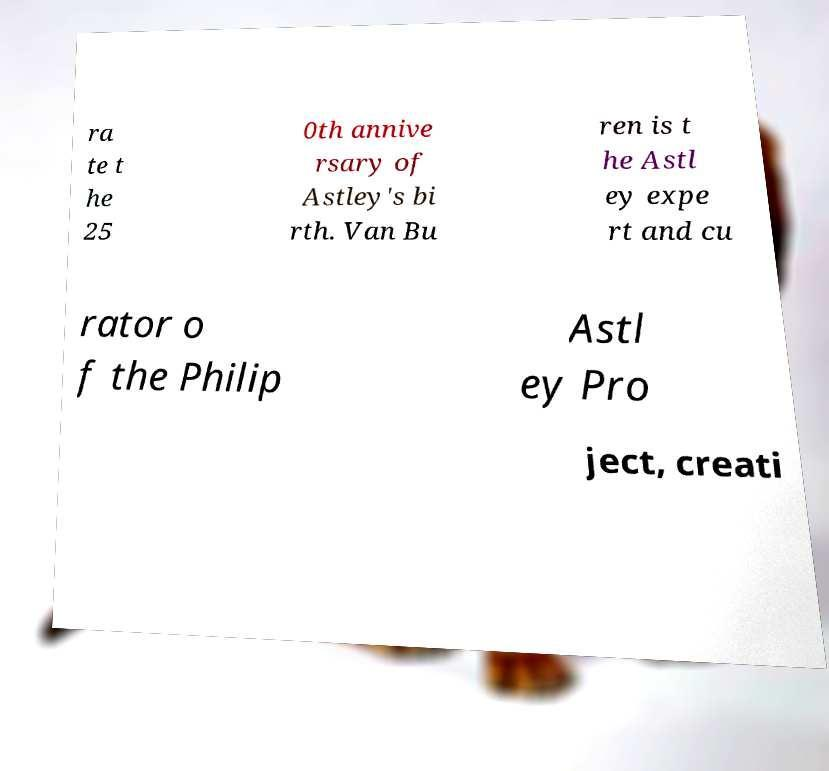Please read and relay the text visible in this image. What does it say? ra te t he 25 0th annive rsary of Astley's bi rth. Van Bu ren is t he Astl ey expe rt and cu rator o f the Philip Astl ey Pro ject, creati 